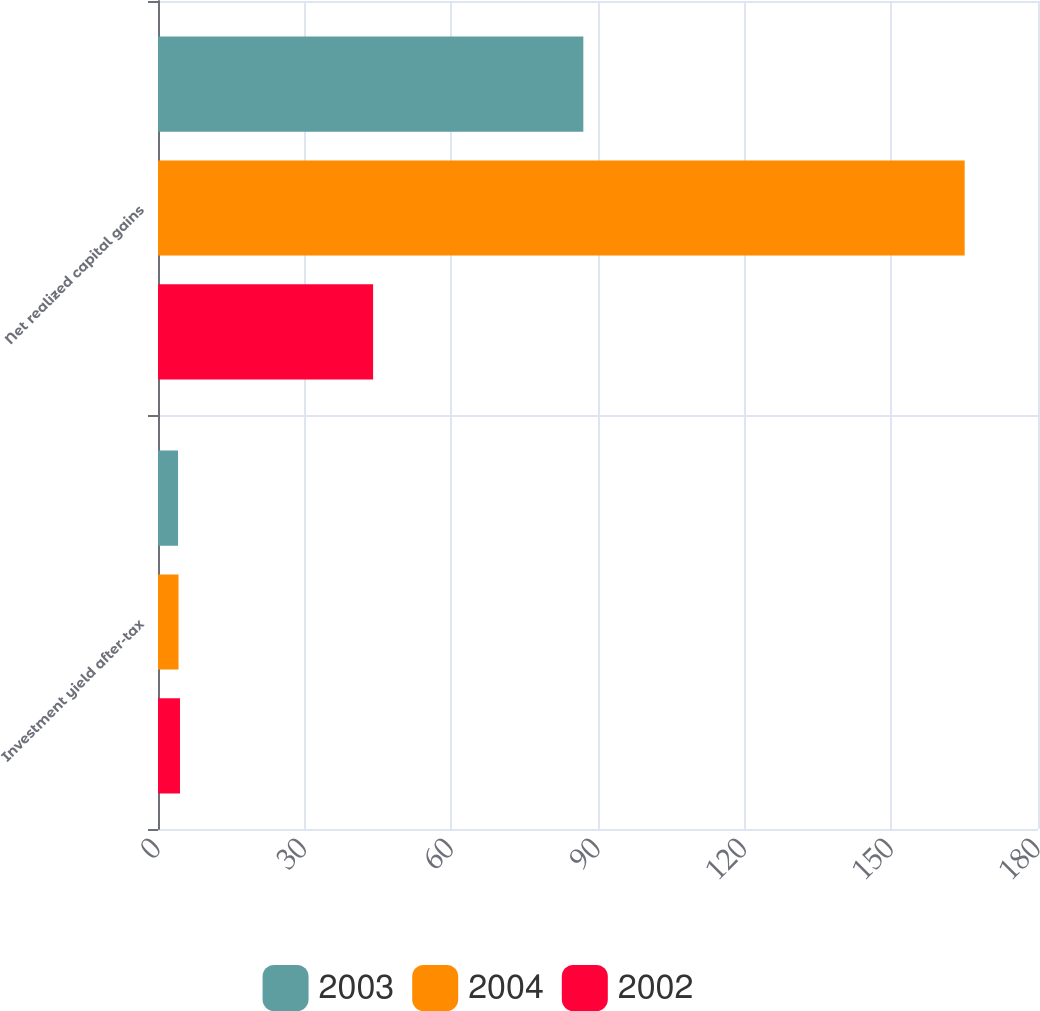Convert chart to OTSL. <chart><loc_0><loc_0><loc_500><loc_500><stacked_bar_chart><ecel><fcel>Investment yield after-tax<fcel>Net realized capital gains<nl><fcel>2003<fcel>4.1<fcel>87<nl><fcel>2004<fcel>4.2<fcel>165<nl><fcel>2002<fcel>4.5<fcel>44<nl></chart> 